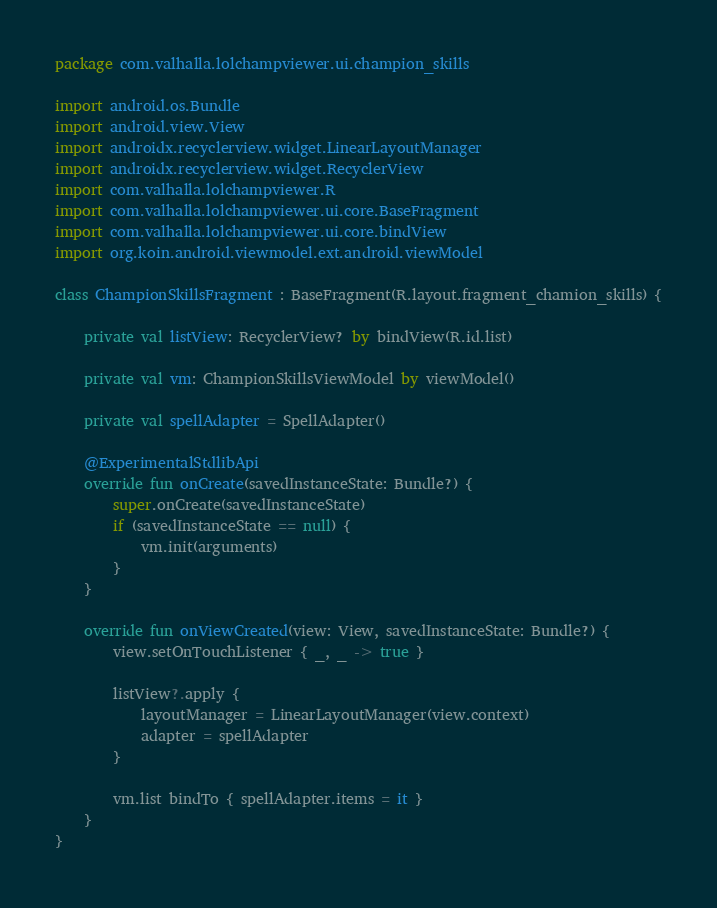<code> <loc_0><loc_0><loc_500><loc_500><_Kotlin_>package com.valhalla.lolchampviewer.ui.champion_skills

import android.os.Bundle
import android.view.View
import androidx.recyclerview.widget.LinearLayoutManager
import androidx.recyclerview.widget.RecyclerView
import com.valhalla.lolchampviewer.R
import com.valhalla.lolchampviewer.ui.core.BaseFragment
import com.valhalla.lolchampviewer.ui.core.bindView
import org.koin.android.viewmodel.ext.android.viewModel

class ChampionSkillsFragment : BaseFragment(R.layout.fragment_chamion_skills) {

    private val listView: RecyclerView? by bindView(R.id.list)

    private val vm: ChampionSkillsViewModel by viewModel()

    private val spellAdapter = SpellAdapter()

    @ExperimentalStdlibApi
    override fun onCreate(savedInstanceState: Bundle?) {
        super.onCreate(savedInstanceState)
        if (savedInstanceState == null) {
            vm.init(arguments)
        }
    }

    override fun onViewCreated(view: View, savedInstanceState: Bundle?) {
        view.setOnTouchListener { _, _ -> true }

        listView?.apply {
            layoutManager = LinearLayoutManager(view.context)
            adapter = spellAdapter
        }

        vm.list bindTo { spellAdapter.items = it }
    }
}</code> 